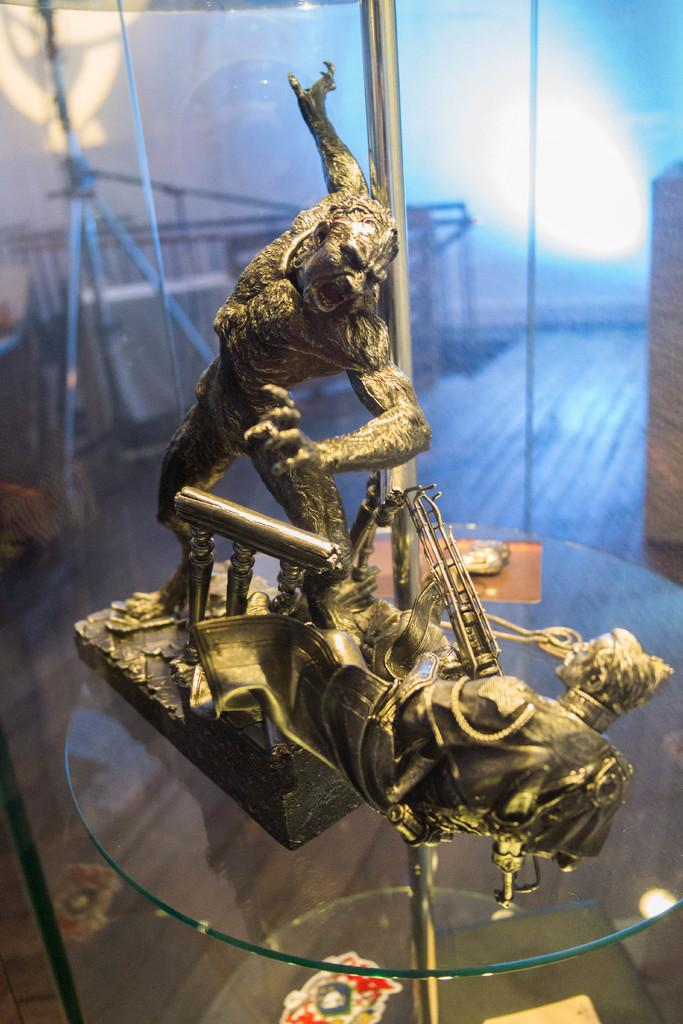What type of table is in the image? There is a glass table in the image. What is placed on the table? There are two sculptures and other unspecified items on the table. What can be seen in the background of the image? There is a stand, a railing, and a light in the background of the image. What type of celery is being used to adjust the watch in the image? There is no celery or watch present in the image. 